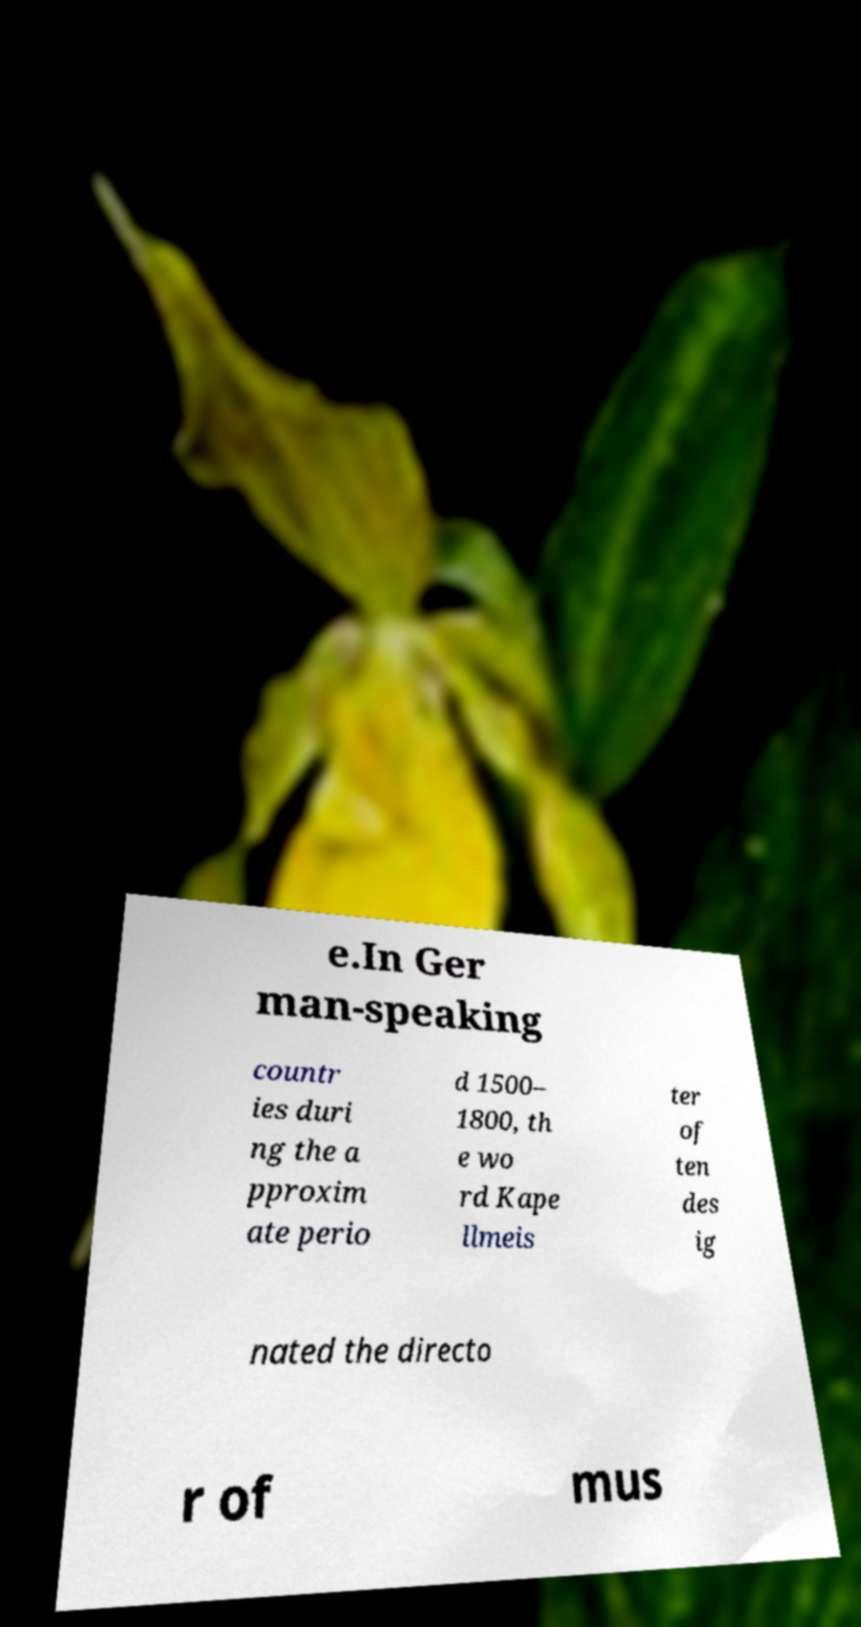Could you extract and type out the text from this image? e.In Ger man-speaking countr ies duri ng the a pproxim ate perio d 1500– 1800, th e wo rd Kape llmeis ter of ten des ig nated the directo r of mus 